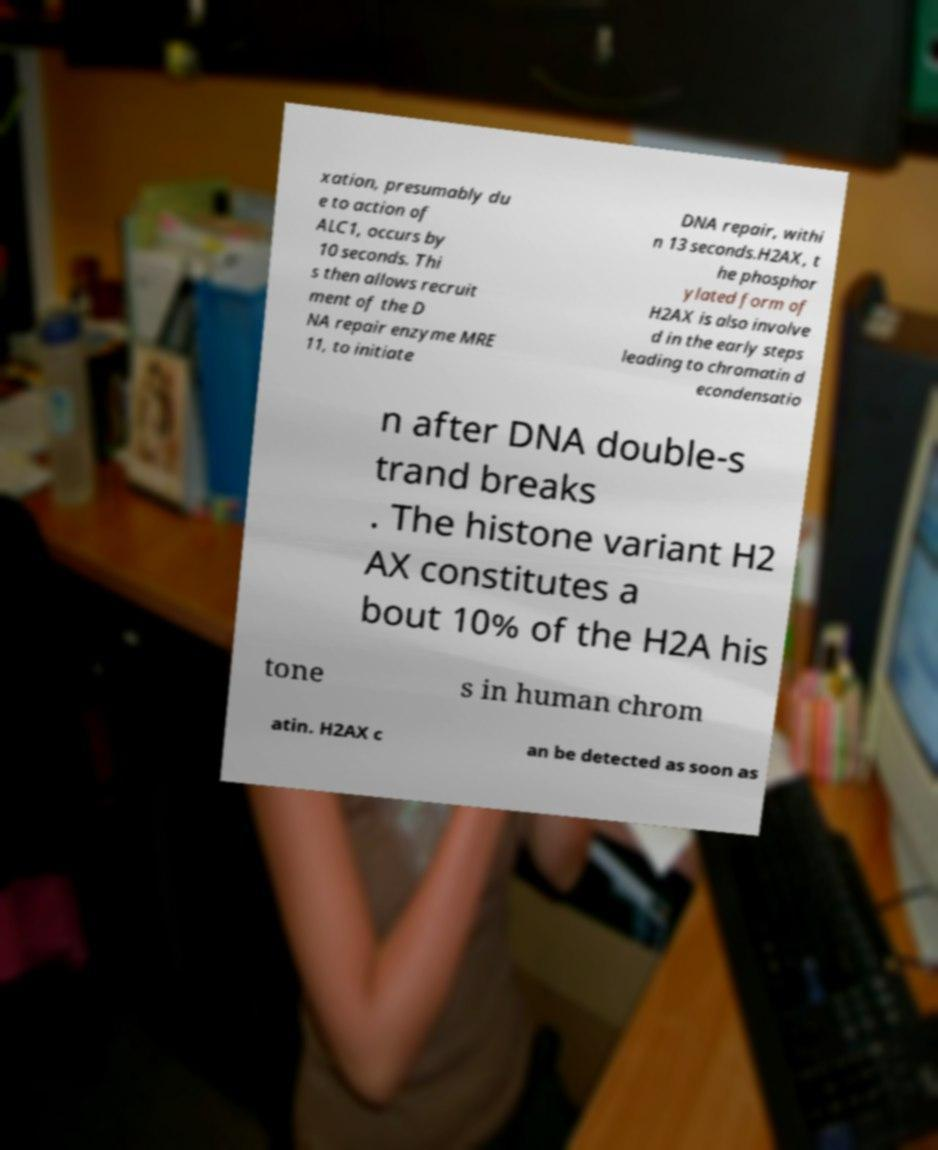Could you assist in decoding the text presented in this image and type it out clearly? xation, presumably du e to action of ALC1, occurs by 10 seconds. Thi s then allows recruit ment of the D NA repair enzyme MRE 11, to initiate DNA repair, withi n 13 seconds.H2AX, t he phosphor ylated form of H2AX is also involve d in the early steps leading to chromatin d econdensatio n after DNA double-s trand breaks . The histone variant H2 AX constitutes a bout 10% of the H2A his tone s in human chrom atin. H2AX c an be detected as soon as 